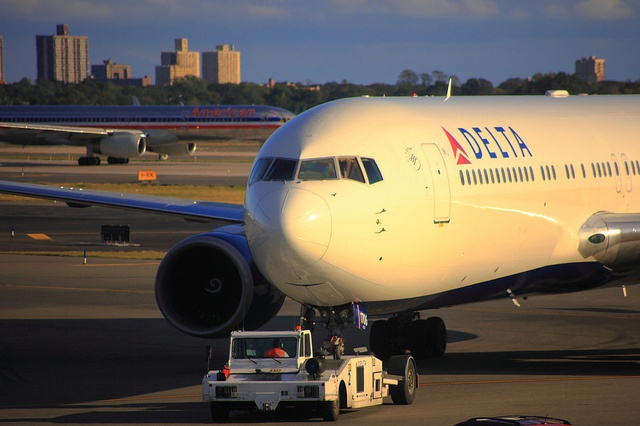Describe the objects in this image and their specific colors. I can see airplane in gray, khaki, black, and tan tones, truck in gray, black, and tan tones, airplane in gray, black, navy, and maroon tones, and people in gray, black, maroon, red, and brown tones in this image. 